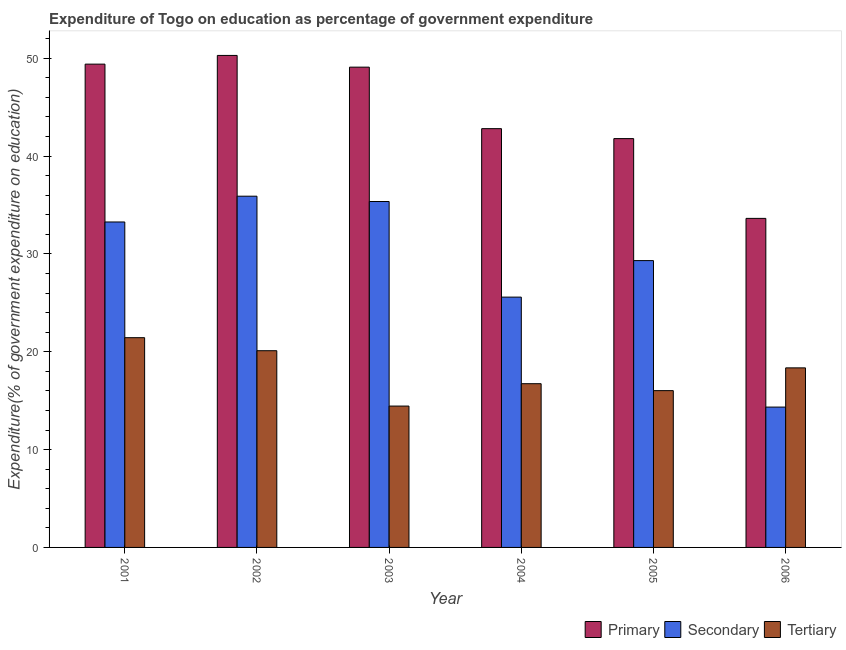How many different coloured bars are there?
Keep it short and to the point. 3. How many groups of bars are there?
Offer a terse response. 6. Are the number of bars on each tick of the X-axis equal?
Make the answer very short. Yes. What is the label of the 2nd group of bars from the left?
Offer a terse response. 2002. What is the expenditure on tertiary education in 2001?
Keep it short and to the point. 21.43. Across all years, what is the maximum expenditure on primary education?
Offer a terse response. 50.28. Across all years, what is the minimum expenditure on primary education?
Give a very brief answer. 33.63. In which year was the expenditure on tertiary education maximum?
Give a very brief answer. 2001. In which year was the expenditure on tertiary education minimum?
Your answer should be very brief. 2003. What is the total expenditure on tertiary education in the graph?
Offer a terse response. 107.09. What is the difference between the expenditure on primary education in 2002 and that in 2006?
Provide a short and direct response. 16.65. What is the difference between the expenditure on primary education in 2002 and the expenditure on tertiary education in 2004?
Your answer should be compact. 7.48. What is the average expenditure on tertiary education per year?
Offer a very short reply. 17.85. In the year 2002, what is the difference between the expenditure on primary education and expenditure on secondary education?
Provide a succinct answer. 0. In how many years, is the expenditure on secondary education greater than 10 %?
Keep it short and to the point. 6. What is the ratio of the expenditure on primary education in 2005 to that in 2006?
Your answer should be compact. 1.24. Is the expenditure on tertiary education in 2002 less than that in 2004?
Your answer should be very brief. No. What is the difference between the highest and the second highest expenditure on secondary education?
Make the answer very short. 0.54. What is the difference between the highest and the lowest expenditure on secondary education?
Your answer should be compact. 21.55. What does the 2nd bar from the left in 2002 represents?
Keep it short and to the point. Secondary. What does the 3rd bar from the right in 2001 represents?
Provide a succinct answer. Primary. Is it the case that in every year, the sum of the expenditure on primary education and expenditure on secondary education is greater than the expenditure on tertiary education?
Offer a very short reply. Yes. How many bars are there?
Offer a very short reply. 18. Are all the bars in the graph horizontal?
Offer a terse response. No. Does the graph contain grids?
Your response must be concise. No. Where does the legend appear in the graph?
Your answer should be very brief. Bottom right. How many legend labels are there?
Provide a succinct answer. 3. How are the legend labels stacked?
Your answer should be very brief. Horizontal. What is the title of the graph?
Give a very brief answer. Expenditure of Togo on education as percentage of government expenditure. Does "Domestic economy" appear as one of the legend labels in the graph?
Keep it short and to the point. No. What is the label or title of the X-axis?
Provide a succinct answer. Year. What is the label or title of the Y-axis?
Keep it short and to the point. Expenditure(% of government expenditure on education). What is the Expenditure(% of government expenditure on education) in Primary in 2001?
Your answer should be very brief. 49.39. What is the Expenditure(% of government expenditure on education) in Secondary in 2001?
Keep it short and to the point. 33.26. What is the Expenditure(% of government expenditure on education) in Tertiary in 2001?
Keep it short and to the point. 21.43. What is the Expenditure(% of government expenditure on education) in Primary in 2002?
Offer a very short reply. 50.28. What is the Expenditure(% of government expenditure on education) in Secondary in 2002?
Ensure brevity in your answer.  35.89. What is the Expenditure(% of government expenditure on education) of Tertiary in 2002?
Provide a succinct answer. 20.1. What is the Expenditure(% of government expenditure on education) of Primary in 2003?
Provide a short and direct response. 49.08. What is the Expenditure(% of government expenditure on education) of Secondary in 2003?
Provide a short and direct response. 35.35. What is the Expenditure(% of government expenditure on education) of Tertiary in 2003?
Give a very brief answer. 14.45. What is the Expenditure(% of government expenditure on education) in Primary in 2004?
Make the answer very short. 42.8. What is the Expenditure(% of government expenditure on education) in Secondary in 2004?
Make the answer very short. 25.58. What is the Expenditure(% of government expenditure on education) of Tertiary in 2004?
Provide a succinct answer. 16.73. What is the Expenditure(% of government expenditure on education) of Primary in 2005?
Provide a short and direct response. 41.78. What is the Expenditure(% of government expenditure on education) in Secondary in 2005?
Ensure brevity in your answer.  29.31. What is the Expenditure(% of government expenditure on education) in Tertiary in 2005?
Provide a short and direct response. 16.02. What is the Expenditure(% of government expenditure on education) in Primary in 2006?
Your answer should be very brief. 33.63. What is the Expenditure(% of government expenditure on education) of Secondary in 2006?
Make the answer very short. 14.34. What is the Expenditure(% of government expenditure on education) of Tertiary in 2006?
Offer a terse response. 18.35. Across all years, what is the maximum Expenditure(% of government expenditure on education) in Primary?
Give a very brief answer. 50.28. Across all years, what is the maximum Expenditure(% of government expenditure on education) of Secondary?
Your answer should be very brief. 35.89. Across all years, what is the maximum Expenditure(% of government expenditure on education) of Tertiary?
Keep it short and to the point. 21.43. Across all years, what is the minimum Expenditure(% of government expenditure on education) in Primary?
Provide a short and direct response. 33.63. Across all years, what is the minimum Expenditure(% of government expenditure on education) in Secondary?
Give a very brief answer. 14.34. Across all years, what is the minimum Expenditure(% of government expenditure on education) of Tertiary?
Your answer should be very brief. 14.45. What is the total Expenditure(% of government expenditure on education) of Primary in the graph?
Keep it short and to the point. 266.95. What is the total Expenditure(% of government expenditure on education) of Secondary in the graph?
Your response must be concise. 173.73. What is the total Expenditure(% of government expenditure on education) of Tertiary in the graph?
Your answer should be very brief. 107.09. What is the difference between the Expenditure(% of government expenditure on education) in Primary in 2001 and that in 2002?
Keep it short and to the point. -0.89. What is the difference between the Expenditure(% of government expenditure on education) in Secondary in 2001 and that in 2002?
Your answer should be compact. -2.63. What is the difference between the Expenditure(% of government expenditure on education) of Tertiary in 2001 and that in 2002?
Provide a succinct answer. 1.33. What is the difference between the Expenditure(% of government expenditure on education) of Primary in 2001 and that in 2003?
Ensure brevity in your answer.  0.31. What is the difference between the Expenditure(% of government expenditure on education) in Secondary in 2001 and that in 2003?
Keep it short and to the point. -2.09. What is the difference between the Expenditure(% of government expenditure on education) of Tertiary in 2001 and that in 2003?
Ensure brevity in your answer.  6.99. What is the difference between the Expenditure(% of government expenditure on education) in Primary in 2001 and that in 2004?
Provide a short and direct response. 6.59. What is the difference between the Expenditure(% of government expenditure on education) of Secondary in 2001 and that in 2004?
Provide a short and direct response. 7.68. What is the difference between the Expenditure(% of government expenditure on education) of Tertiary in 2001 and that in 2004?
Ensure brevity in your answer.  4.7. What is the difference between the Expenditure(% of government expenditure on education) in Primary in 2001 and that in 2005?
Provide a short and direct response. 7.61. What is the difference between the Expenditure(% of government expenditure on education) in Secondary in 2001 and that in 2005?
Ensure brevity in your answer.  3.95. What is the difference between the Expenditure(% of government expenditure on education) of Tertiary in 2001 and that in 2005?
Offer a terse response. 5.41. What is the difference between the Expenditure(% of government expenditure on education) of Primary in 2001 and that in 2006?
Your answer should be very brief. 15.76. What is the difference between the Expenditure(% of government expenditure on education) in Secondary in 2001 and that in 2006?
Offer a terse response. 18.92. What is the difference between the Expenditure(% of government expenditure on education) in Tertiary in 2001 and that in 2006?
Keep it short and to the point. 3.09. What is the difference between the Expenditure(% of government expenditure on education) in Primary in 2002 and that in 2003?
Provide a succinct answer. 1.2. What is the difference between the Expenditure(% of government expenditure on education) of Secondary in 2002 and that in 2003?
Your response must be concise. 0.54. What is the difference between the Expenditure(% of government expenditure on education) of Tertiary in 2002 and that in 2003?
Make the answer very short. 5.66. What is the difference between the Expenditure(% of government expenditure on education) in Primary in 2002 and that in 2004?
Your response must be concise. 7.48. What is the difference between the Expenditure(% of government expenditure on education) of Secondary in 2002 and that in 2004?
Provide a succinct answer. 10.31. What is the difference between the Expenditure(% of government expenditure on education) in Tertiary in 2002 and that in 2004?
Your answer should be very brief. 3.37. What is the difference between the Expenditure(% of government expenditure on education) in Primary in 2002 and that in 2005?
Offer a terse response. 8.5. What is the difference between the Expenditure(% of government expenditure on education) of Secondary in 2002 and that in 2005?
Your response must be concise. 6.58. What is the difference between the Expenditure(% of government expenditure on education) of Tertiary in 2002 and that in 2005?
Provide a succinct answer. 4.08. What is the difference between the Expenditure(% of government expenditure on education) in Primary in 2002 and that in 2006?
Your response must be concise. 16.65. What is the difference between the Expenditure(% of government expenditure on education) in Secondary in 2002 and that in 2006?
Make the answer very short. 21.55. What is the difference between the Expenditure(% of government expenditure on education) of Tertiary in 2002 and that in 2006?
Provide a short and direct response. 1.75. What is the difference between the Expenditure(% of government expenditure on education) of Primary in 2003 and that in 2004?
Your response must be concise. 6.29. What is the difference between the Expenditure(% of government expenditure on education) of Secondary in 2003 and that in 2004?
Offer a terse response. 9.77. What is the difference between the Expenditure(% of government expenditure on education) in Tertiary in 2003 and that in 2004?
Offer a very short reply. -2.29. What is the difference between the Expenditure(% of government expenditure on education) in Primary in 2003 and that in 2005?
Give a very brief answer. 7.3. What is the difference between the Expenditure(% of government expenditure on education) in Secondary in 2003 and that in 2005?
Offer a very short reply. 6.04. What is the difference between the Expenditure(% of government expenditure on education) in Tertiary in 2003 and that in 2005?
Your response must be concise. -1.58. What is the difference between the Expenditure(% of government expenditure on education) of Primary in 2003 and that in 2006?
Provide a succinct answer. 15.46. What is the difference between the Expenditure(% of government expenditure on education) in Secondary in 2003 and that in 2006?
Provide a succinct answer. 21.01. What is the difference between the Expenditure(% of government expenditure on education) of Tertiary in 2003 and that in 2006?
Your response must be concise. -3.9. What is the difference between the Expenditure(% of government expenditure on education) of Secondary in 2004 and that in 2005?
Ensure brevity in your answer.  -3.73. What is the difference between the Expenditure(% of government expenditure on education) of Tertiary in 2004 and that in 2005?
Provide a short and direct response. 0.71. What is the difference between the Expenditure(% of government expenditure on education) in Primary in 2004 and that in 2006?
Keep it short and to the point. 9.17. What is the difference between the Expenditure(% of government expenditure on education) of Secondary in 2004 and that in 2006?
Offer a very short reply. 11.24. What is the difference between the Expenditure(% of government expenditure on education) of Tertiary in 2004 and that in 2006?
Provide a succinct answer. -1.62. What is the difference between the Expenditure(% of government expenditure on education) of Primary in 2005 and that in 2006?
Make the answer very short. 8.15. What is the difference between the Expenditure(% of government expenditure on education) in Secondary in 2005 and that in 2006?
Your answer should be compact. 14.97. What is the difference between the Expenditure(% of government expenditure on education) in Tertiary in 2005 and that in 2006?
Your response must be concise. -2.33. What is the difference between the Expenditure(% of government expenditure on education) of Primary in 2001 and the Expenditure(% of government expenditure on education) of Secondary in 2002?
Your response must be concise. 13.5. What is the difference between the Expenditure(% of government expenditure on education) in Primary in 2001 and the Expenditure(% of government expenditure on education) in Tertiary in 2002?
Your response must be concise. 29.29. What is the difference between the Expenditure(% of government expenditure on education) in Secondary in 2001 and the Expenditure(% of government expenditure on education) in Tertiary in 2002?
Make the answer very short. 13.16. What is the difference between the Expenditure(% of government expenditure on education) in Primary in 2001 and the Expenditure(% of government expenditure on education) in Secondary in 2003?
Make the answer very short. 14.04. What is the difference between the Expenditure(% of government expenditure on education) in Primary in 2001 and the Expenditure(% of government expenditure on education) in Tertiary in 2003?
Your answer should be very brief. 34.94. What is the difference between the Expenditure(% of government expenditure on education) of Secondary in 2001 and the Expenditure(% of government expenditure on education) of Tertiary in 2003?
Provide a short and direct response. 18.81. What is the difference between the Expenditure(% of government expenditure on education) in Primary in 2001 and the Expenditure(% of government expenditure on education) in Secondary in 2004?
Provide a short and direct response. 23.81. What is the difference between the Expenditure(% of government expenditure on education) in Primary in 2001 and the Expenditure(% of government expenditure on education) in Tertiary in 2004?
Give a very brief answer. 32.66. What is the difference between the Expenditure(% of government expenditure on education) of Secondary in 2001 and the Expenditure(% of government expenditure on education) of Tertiary in 2004?
Ensure brevity in your answer.  16.53. What is the difference between the Expenditure(% of government expenditure on education) of Primary in 2001 and the Expenditure(% of government expenditure on education) of Secondary in 2005?
Offer a terse response. 20.08. What is the difference between the Expenditure(% of government expenditure on education) in Primary in 2001 and the Expenditure(% of government expenditure on education) in Tertiary in 2005?
Make the answer very short. 33.37. What is the difference between the Expenditure(% of government expenditure on education) of Secondary in 2001 and the Expenditure(% of government expenditure on education) of Tertiary in 2005?
Keep it short and to the point. 17.24. What is the difference between the Expenditure(% of government expenditure on education) of Primary in 2001 and the Expenditure(% of government expenditure on education) of Secondary in 2006?
Ensure brevity in your answer.  35.05. What is the difference between the Expenditure(% of government expenditure on education) of Primary in 2001 and the Expenditure(% of government expenditure on education) of Tertiary in 2006?
Your response must be concise. 31.04. What is the difference between the Expenditure(% of government expenditure on education) of Secondary in 2001 and the Expenditure(% of government expenditure on education) of Tertiary in 2006?
Ensure brevity in your answer.  14.91. What is the difference between the Expenditure(% of government expenditure on education) in Primary in 2002 and the Expenditure(% of government expenditure on education) in Secondary in 2003?
Provide a succinct answer. 14.93. What is the difference between the Expenditure(% of government expenditure on education) of Primary in 2002 and the Expenditure(% of government expenditure on education) of Tertiary in 2003?
Your answer should be very brief. 35.83. What is the difference between the Expenditure(% of government expenditure on education) of Secondary in 2002 and the Expenditure(% of government expenditure on education) of Tertiary in 2003?
Keep it short and to the point. 21.45. What is the difference between the Expenditure(% of government expenditure on education) in Primary in 2002 and the Expenditure(% of government expenditure on education) in Secondary in 2004?
Ensure brevity in your answer.  24.7. What is the difference between the Expenditure(% of government expenditure on education) of Primary in 2002 and the Expenditure(% of government expenditure on education) of Tertiary in 2004?
Offer a very short reply. 33.55. What is the difference between the Expenditure(% of government expenditure on education) of Secondary in 2002 and the Expenditure(% of government expenditure on education) of Tertiary in 2004?
Your response must be concise. 19.16. What is the difference between the Expenditure(% of government expenditure on education) of Primary in 2002 and the Expenditure(% of government expenditure on education) of Secondary in 2005?
Make the answer very short. 20.97. What is the difference between the Expenditure(% of government expenditure on education) in Primary in 2002 and the Expenditure(% of government expenditure on education) in Tertiary in 2005?
Your answer should be compact. 34.26. What is the difference between the Expenditure(% of government expenditure on education) of Secondary in 2002 and the Expenditure(% of government expenditure on education) of Tertiary in 2005?
Give a very brief answer. 19.87. What is the difference between the Expenditure(% of government expenditure on education) of Primary in 2002 and the Expenditure(% of government expenditure on education) of Secondary in 2006?
Keep it short and to the point. 35.94. What is the difference between the Expenditure(% of government expenditure on education) in Primary in 2002 and the Expenditure(% of government expenditure on education) in Tertiary in 2006?
Provide a succinct answer. 31.93. What is the difference between the Expenditure(% of government expenditure on education) of Secondary in 2002 and the Expenditure(% of government expenditure on education) of Tertiary in 2006?
Ensure brevity in your answer.  17.54. What is the difference between the Expenditure(% of government expenditure on education) of Primary in 2003 and the Expenditure(% of government expenditure on education) of Secondary in 2004?
Your response must be concise. 23.5. What is the difference between the Expenditure(% of government expenditure on education) in Primary in 2003 and the Expenditure(% of government expenditure on education) in Tertiary in 2004?
Offer a terse response. 32.35. What is the difference between the Expenditure(% of government expenditure on education) of Secondary in 2003 and the Expenditure(% of government expenditure on education) of Tertiary in 2004?
Offer a terse response. 18.62. What is the difference between the Expenditure(% of government expenditure on education) in Primary in 2003 and the Expenditure(% of government expenditure on education) in Secondary in 2005?
Your answer should be very brief. 19.77. What is the difference between the Expenditure(% of government expenditure on education) in Primary in 2003 and the Expenditure(% of government expenditure on education) in Tertiary in 2005?
Your answer should be compact. 33.06. What is the difference between the Expenditure(% of government expenditure on education) of Secondary in 2003 and the Expenditure(% of government expenditure on education) of Tertiary in 2005?
Provide a short and direct response. 19.33. What is the difference between the Expenditure(% of government expenditure on education) in Primary in 2003 and the Expenditure(% of government expenditure on education) in Secondary in 2006?
Offer a very short reply. 34.74. What is the difference between the Expenditure(% of government expenditure on education) of Primary in 2003 and the Expenditure(% of government expenditure on education) of Tertiary in 2006?
Your answer should be compact. 30.73. What is the difference between the Expenditure(% of government expenditure on education) of Secondary in 2003 and the Expenditure(% of government expenditure on education) of Tertiary in 2006?
Ensure brevity in your answer.  17. What is the difference between the Expenditure(% of government expenditure on education) of Primary in 2004 and the Expenditure(% of government expenditure on education) of Secondary in 2005?
Offer a terse response. 13.48. What is the difference between the Expenditure(% of government expenditure on education) in Primary in 2004 and the Expenditure(% of government expenditure on education) in Tertiary in 2005?
Offer a very short reply. 26.77. What is the difference between the Expenditure(% of government expenditure on education) of Secondary in 2004 and the Expenditure(% of government expenditure on education) of Tertiary in 2005?
Give a very brief answer. 9.56. What is the difference between the Expenditure(% of government expenditure on education) in Primary in 2004 and the Expenditure(% of government expenditure on education) in Secondary in 2006?
Offer a terse response. 28.45. What is the difference between the Expenditure(% of government expenditure on education) of Primary in 2004 and the Expenditure(% of government expenditure on education) of Tertiary in 2006?
Offer a very short reply. 24.45. What is the difference between the Expenditure(% of government expenditure on education) of Secondary in 2004 and the Expenditure(% of government expenditure on education) of Tertiary in 2006?
Keep it short and to the point. 7.23. What is the difference between the Expenditure(% of government expenditure on education) of Primary in 2005 and the Expenditure(% of government expenditure on education) of Secondary in 2006?
Your answer should be compact. 27.44. What is the difference between the Expenditure(% of government expenditure on education) in Primary in 2005 and the Expenditure(% of government expenditure on education) in Tertiary in 2006?
Your response must be concise. 23.43. What is the difference between the Expenditure(% of government expenditure on education) in Secondary in 2005 and the Expenditure(% of government expenditure on education) in Tertiary in 2006?
Ensure brevity in your answer.  10.96. What is the average Expenditure(% of government expenditure on education) of Primary per year?
Offer a terse response. 44.49. What is the average Expenditure(% of government expenditure on education) in Secondary per year?
Offer a very short reply. 28.96. What is the average Expenditure(% of government expenditure on education) in Tertiary per year?
Your response must be concise. 17.85. In the year 2001, what is the difference between the Expenditure(% of government expenditure on education) of Primary and Expenditure(% of government expenditure on education) of Secondary?
Make the answer very short. 16.13. In the year 2001, what is the difference between the Expenditure(% of government expenditure on education) in Primary and Expenditure(% of government expenditure on education) in Tertiary?
Your answer should be compact. 27.95. In the year 2001, what is the difference between the Expenditure(% of government expenditure on education) of Secondary and Expenditure(% of government expenditure on education) of Tertiary?
Your response must be concise. 11.82. In the year 2002, what is the difference between the Expenditure(% of government expenditure on education) of Primary and Expenditure(% of government expenditure on education) of Secondary?
Your response must be concise. 14.39. In the year 2002, what is the difference between the Expenditure(% of government expenditure on education) of Primary and Expenditure(% of government expenditure on education) of Tertiary?
Your response must be concise. 30.18. In the year 2002, what is the difference between the Expenditure(% of government expenditure on education) in Secondary and Expenditure(% of government expenditure on education) in Tertiary?
Your answer should be very brief. 15.79. In the year 2003, what is the difference between the Expenditure(% of government expenditure on education) in Primary and Expenditure(% of government expenditure on education) in Secondary?
Offer a terse response. 13.73. In the year 2003, what is the difference between the Expenditure(% of government expenditure on education) of Primary and Expenditure(% of government expenditure on education) of Tertiary?
Offer a terse response. 34.63. In the year 2003, what is the difference between the Expenditure(% of government expenditure on education) of Secondary and Expenditure(% of government expenditure on education) of Tertiary?
Give a very brief answer. 20.9. In the year 2004, what is the difference between the Expenditure(% of government expenditure on education) in Primary and Expenditure(% of government expenditure on education) in Secondary?
Your answer should be very brief. 17.22. In the year 2004, what is the difference between the Expenditure(% of government expenditure on education) of Primary and Expenditure(% of government expenditure on education) of Tertiary?
Give a very brief answer. 26.06. In the year 2004, what is the difference between the Expenditure(% of government expenditure on education) of Secondary and Expenditure(% of government expenditure on education) of Tertiary?
Offer a terse response. 8.85. In the year 2005, what is the difference between the Expenditure(% of government expenditure on education) of Primary and Expenditure(% of government expenditure on education) of Secondary?
Your response must be concise. 12.47. In the year 2005, what is the difference between the Expenditure(% of government expenditure on education) of Primary and Expenditure(% of government expenditure on education) of Tertiary?
Provide a short and direct response. 25.76. In the year 2005, what is the difference between the Expenditure(% of government expenditure on education) of Secondary and Expenditure(% of government expenditure on education) of Tertiary?
Make the answer very short. 13.29. In the year 2006, what is the difference between the Expenditure(% of government expenditure on education) in Primary and Expenditure(% of government expenditure on education) in Secondary?
Your answer should be very brief. 19.28. In the year 2006, what is the difference between the Expenditure(% of government expenditure on education) of Primary and Expenditure(% of government expenditure on education) of Tertiary?
Offer a very short reply. 15.28. In the year 2006, what is the difference between the Expenditure(% of government expenditure on education) of Secondary and Expenditure(% of government expenditure on education) of Tertiary?
Your response must be concise. -4.01. What is the ratio of the Expenditure(% of government expenditure on education) in Primary in 2001 to that in 2002?
Offer a very short reply. 0.98. What is the ratio of the Expenditure(% of government expenditure on education) of Secondary in 2001 to that in 2002?
Give a very brief answer. 0.93. What is the ratio of the Expenditure(% of government expenditure on education) of Tertiary in 2001 to that in 2002?
Your answer should be compact. 1.07. What is the ratio of the Expenditure(% of government expenditure on education) in Primary in 2001 to that in 2003?
Keep it short and to the point. 1.01. What is the ratio of the Expenditure(% of government expenditure on education) of Secondary in 2001 to that in 2003?
Keep it short and to the point. 0.94. What is the ratio of the Expenditure(% of government expenditure on education) of Tertiary in 2001 to that in 2003?
Make the answer very short. 1.48. What is the ratio of the Expenditure(% of government expenditure on education) of Primary in 2001 to that in 2004?
Offer a very short reply. 1.15. What is the ratio of the Expenditure(% of government expenditure on education) in Secondary in 2001 to that in 2004?
Make the answer very short. 1.3. What is the ratio of the Expenditure(% of government expenditure on education) of Tertiary in 2001 to that in 2004?
Your answer should be compact. 1.28. What is the ratio of the Expenditure(% of government expenditure on education) in Primary in 2001 to that in 2005?
Ensure brevity in your answer.  1.18. What is the ratio of the Expenditure(% of government expenditure on education) in Secondary in 2001 to that in 2005?
Your answer should be very brief. 1.13. What is the ratio of the Expenditure(% of government expenditure on education) of Tertiary in 2001 to that in 2005?
Keep it short and to the point. 1.34. What is the ratio of the Expenditure(% of government expenditure on education) of Primary in 2001 to that in 2006?
Your response must be concise. 1.47. What is the ratio of the Expenditure(% of government expenditure on education) in Secondary in 2001 to that in 2006?
Make the answer very short. 2.32. What is the ratio of the Expenditure(% of government expenditure on education) of Tertiary in 2001 to that in 2006?
Ensure brevity in your answer.  1.17. What is the ratio of the Expenditure(% of government expenditure on education) of Primary in 2002 to that in 2003?
Provide a succinct answer. 1.02. What is the ratio of the Expenditure(% of government expenditure on education) in Secondary in 2002 to that in 2003?
Keep it short and to the point. 1.02. What is the ratio of the Expenditure(% of government expenditure on education) in Tertiary in 2002 to that in 2003?
Make the answer very short. 1.39. What is the ratio of the Expenditure(% of government expenditure on education) in Primary in 2002 to that in 2004?
Keep it short and to the point. 1.17. What is the ratio of the Expenditure(% of government expenditure on education) of Secondary in 2002 to that in 2004?
Ensure brevity in your answer.  1.4. What is the ratio of the Expenditure(% of government expenditure on education) of Tertiary in 2002 to that in 2004?
Give a very brief answer. 1.2. What is the ratio of the Expenditure(% of government expenditure on education) in Primary in 2002 to that in 2005?
Your answer should be compact. 1.2. What is the ratio of the Expenditure(% of government expenditure on education) of Secondary in 2002 to that in 2005?
Your answer should be very brief. 1.22. What is the ratio of the Expenditure(% of government expenditure on education) in Tertiary in 2002 to that in 2005?
Offer a terse response. 1.25. What is the ratio of the Expenditure(% of government expenditure on education) in Primary in 2002 to that in 2006?
Give a very brief answer. 1.5. What is the ratio of the Expenditure(% of government expenditure on education) of Secondary in 2002 to that in 2006?
Your answer should be very brief. 2.5. What is the ratio of the Expenditure(% of government expenditure on education) in Tertiary in 2002 to that in 2006?
Your response must be concise. 1.1. What is the ratio of the Expenditure(% of government expenditure on education) of Primary in 2003 to that in 2004?
Provide a short and direct response. 1.15. What is the ratio of the Expenditure(% of government expenditure on education) in Secondary in 2003 to that in 2004?
Make the answer very short. 1.38. What is the ratio of the Expenditure(% of government expenditure on education) in Tertiary in 2003 to that in 2004?
Your answer should be compact. 0.86. What is the ratio of the Expenditure(% of government expenditure on education) of Primary in 2003 to that in 2005?
Keep it short and to the point. 1.17. What is the ratio of the Expenditure(% of government expenditure on education) in Secondary in 2003 to that in 2005?
Make the answer very short. 1.21. What is the ratio of the Expenditure(% of government expenditure on education) of Tertiary in 2003 to that in 2005?
Give a very brief answer. 0.9. What is the ratio of the Expenditure(% of government expenditure on education) of Primary in 2003 to that in 2006?
Your response must be concise. 1.46. What is the ratio of the Expenditure(% of government expenditure on education) in Secondary in 2003 to that in 2006?
Keep it short and to the point. 2.46. What is the ratio of the Expenditure(% of government expenditure on education) of Tertiary in 2003 to that in 2006?
Keep it short and to the point. 0.79. What is the ratio of the Expenditure(% of government expenditure on education) of Primary in 2004 to that in 2005?
Give a very brief answer. 1.02. What is the ratio of the Expenditure(% of government expenditure on education) in Secondary in 2004 to that in 2005?
Your answer should be very brief. 0.87. What is the ratio of the Expenditure(% of government expenditure on education) of Tertiary in 2004 to that in 2005?
Offer a terse response. 1.04. What is the ratio of the Expenditure(% of government expenditure on education) in Primary in 2004 to that in 2006?
Your response must be concise. 1.27. What is the ratio of the Expenditure(% of government expenditure on education) in Secondary in 2004 to that in 2006?
Offer a terse response. 1.78. What is the ratio of the Expenditure(% of government expenditure on education) in Tertiary in 2004 to that in 2006?
Give a very brief answer. 0.91. What is the ratio of the Expenditure(% of government expenditure on education) in Primary in 2005 to that in 2006?
Keep it short and to the point. 1.24. What is the ratio of the Expenditure(% of government expenditure on education) in Secondary in 2005 to that in 2006?
Your answer should be very brief. 2.04. What is the ratio of the Expenditure(% of government expenditure on education) of Tertiary in 2005 to that in 2006?
Your answer should be very brief. 0.87. What is the difference between the highest and the second highest Expenditure(% of government expenditure on education) of Primary?
Ensure brevity in your answer.  0.89. What is the difference between the highest and the second highest Expenditure(% of government expenditure on education) of Secondary?
Your answer should be compact. 0.54. What is the difference between the highest and the second highest Expenditure(% of government expenditure on education) of Tertiary?
Your answer should be very brief. 1.33. What is the difference between the highest and the lowest Expenditure(% of government expenditure on education) of Primary?
Ensure brevity in your answer.  16.65. What is the difference between the highest and the lowest Expenditure(% of government expenditure on education) in Secondary?
Offer a very short reply. 21.55. What is the difference between the highest and the lowest Expenditure(% of government expenditure on education) in Tertiary?
Keep it short and to the point. 6.99. 